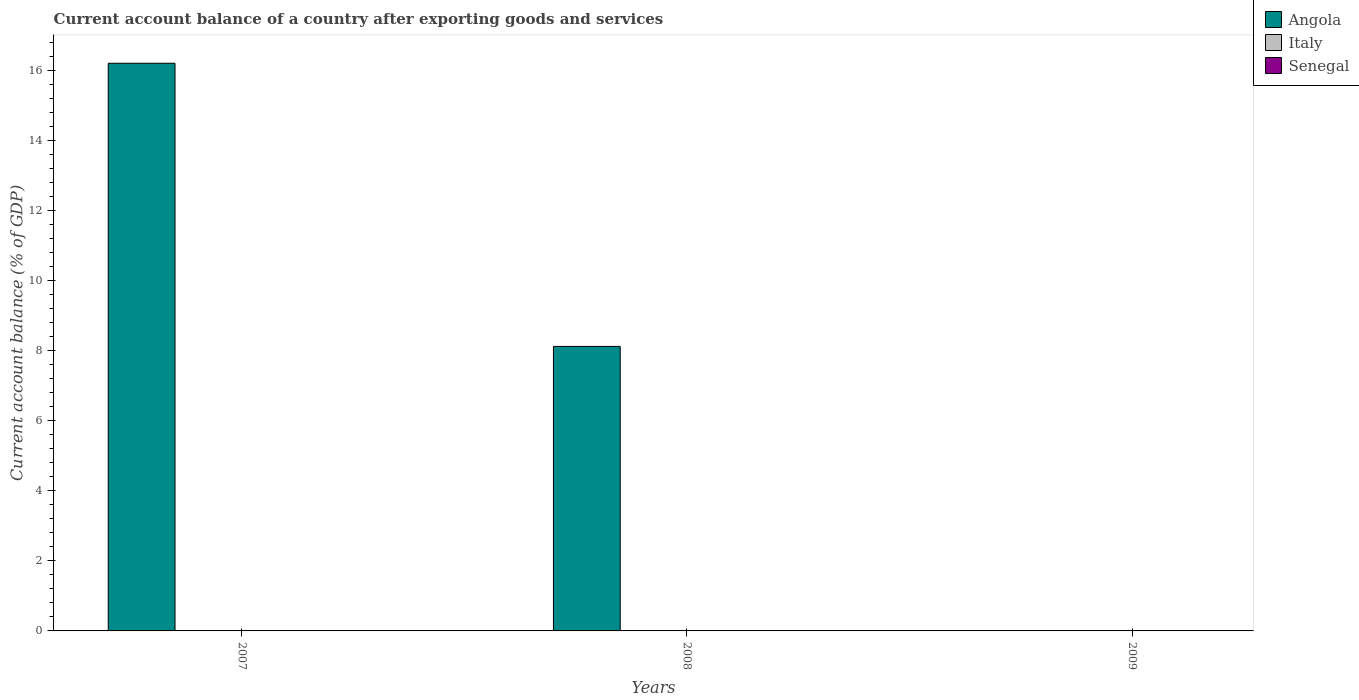How many different coloured bars are there?
Offer a very short reply. 1. Are the number of bars per tick equal to the number of legend labels?
Your answer should be compact. No. How many bars are there on the 2nd tick from the left?
Offer a terse response. 1. How many bars are there on the 2nd tick from the right?
Make the answer very short. 1. What is the label of the 3rd group of bars from the left?
Keep it short and to the point. 2009. In how many cases, is the number of bars for a given year not equal to the number of legend labels?
Give a very brief answer. 3. Across all years, what is the maximum account balance in Angola?
Offer a very short reply. 16.21. Across all years, what is the minimum account balance in Angola?
Your response must be concise. 0. In which year was the account balance in Angola maximum?
Your answer should be compact. 2007. What is the difference between the account balance in Angola in 2007 and that in 2008?
Make the answer very short. 8.09. What is the difference between the account balance in Italy in 2008 and the account balance in Senegal in 2009?
Provide a succinct answer. 0. What is the average account balance in Angola per year?
Offer a terse response. 8.11. In how many years, is the account balance in Italy greater than 9.2 %?
Offer a terse response. 0. What is the difference between the highest and the lowest account balance in Angola?
Ensure brevity in your answer.  16.21. In how many years, is the account balance in Senegal greater than the average account balance in Senegal taken over all years?
Offer a terse response. 0. Is it the case that in every year, the sum of the account balance in Angola and account balance in Senegal is greater than the account balance in Italy?
Keep it short and to the point. No. How many bars are there?
Your answer should be very brief. 2. How many years are there in the graph?
Offer a terse response. 3. How are the legend labels stacked?
Provide a short and direct response. Vertical. What is the title of the graph?
Offer a very short reply. Current account balance of a country after exporting goods and services. What is the label or title of the Y-axis?
Make the answer very short. Current account balance (% of GDP). What is the Current account balance (% of GDP) in Angola in 2007?
Give a very brief answer. 16.21. What is the Current account balance (% of GDP) in Senegal in 2007?
Provide a short and direct response. 0. What is the Current account balance (% of GDP) in Angola in 2008?
Keep it short and to the point. 8.13. What is the Current account balance (% of GDP) of Italy in 2009?
Your answer should be compact. 0. What is the Current account balance (% of GDP) in Senegal in 2009?
Provide a short and direct response. 0. Across all years, what is the maximum Current account balance (% of GDP) in Angola?
Your answer should be compact. 16.21. Across all years, what is the minimum Current account balance (% of GDP) of Angola?
Your response must be concise. 0. What is the total Current account balance (% of GDP) of Angola in the graph?
Give a very brief answer. 24.34. What is the total Current account balance (% of GDP) in Italy in the graph?
Keep it short and to the point. 0. What is the total Current account balance (% of GDP) in Senegal in the graph?
Offer a terse response. 0. What is the difference between the Current account balance (% of GDP) in Angola in 2007 and that in 2008?
Offer a terse response. 8.09. What is the average Current account balance (% of GDP) of Angola per year?
Give a very brief answer. 8.11. What is the average Current account balance (% of GDP) in Italy per year?
Provide a succinct answer. 0. What is the average Current account balance (% of GDP) of Senegal per year?
Make the answer very short. 0. What is the ratio of the Current account balance (% of GDP) in Angola in 2007 to that in 2008?
Your answer should be very brief. 2. What is the difference between the highest and the lowest Current account balance (% of GDP) of Angola?
Offer a very short reply. 16.21. 